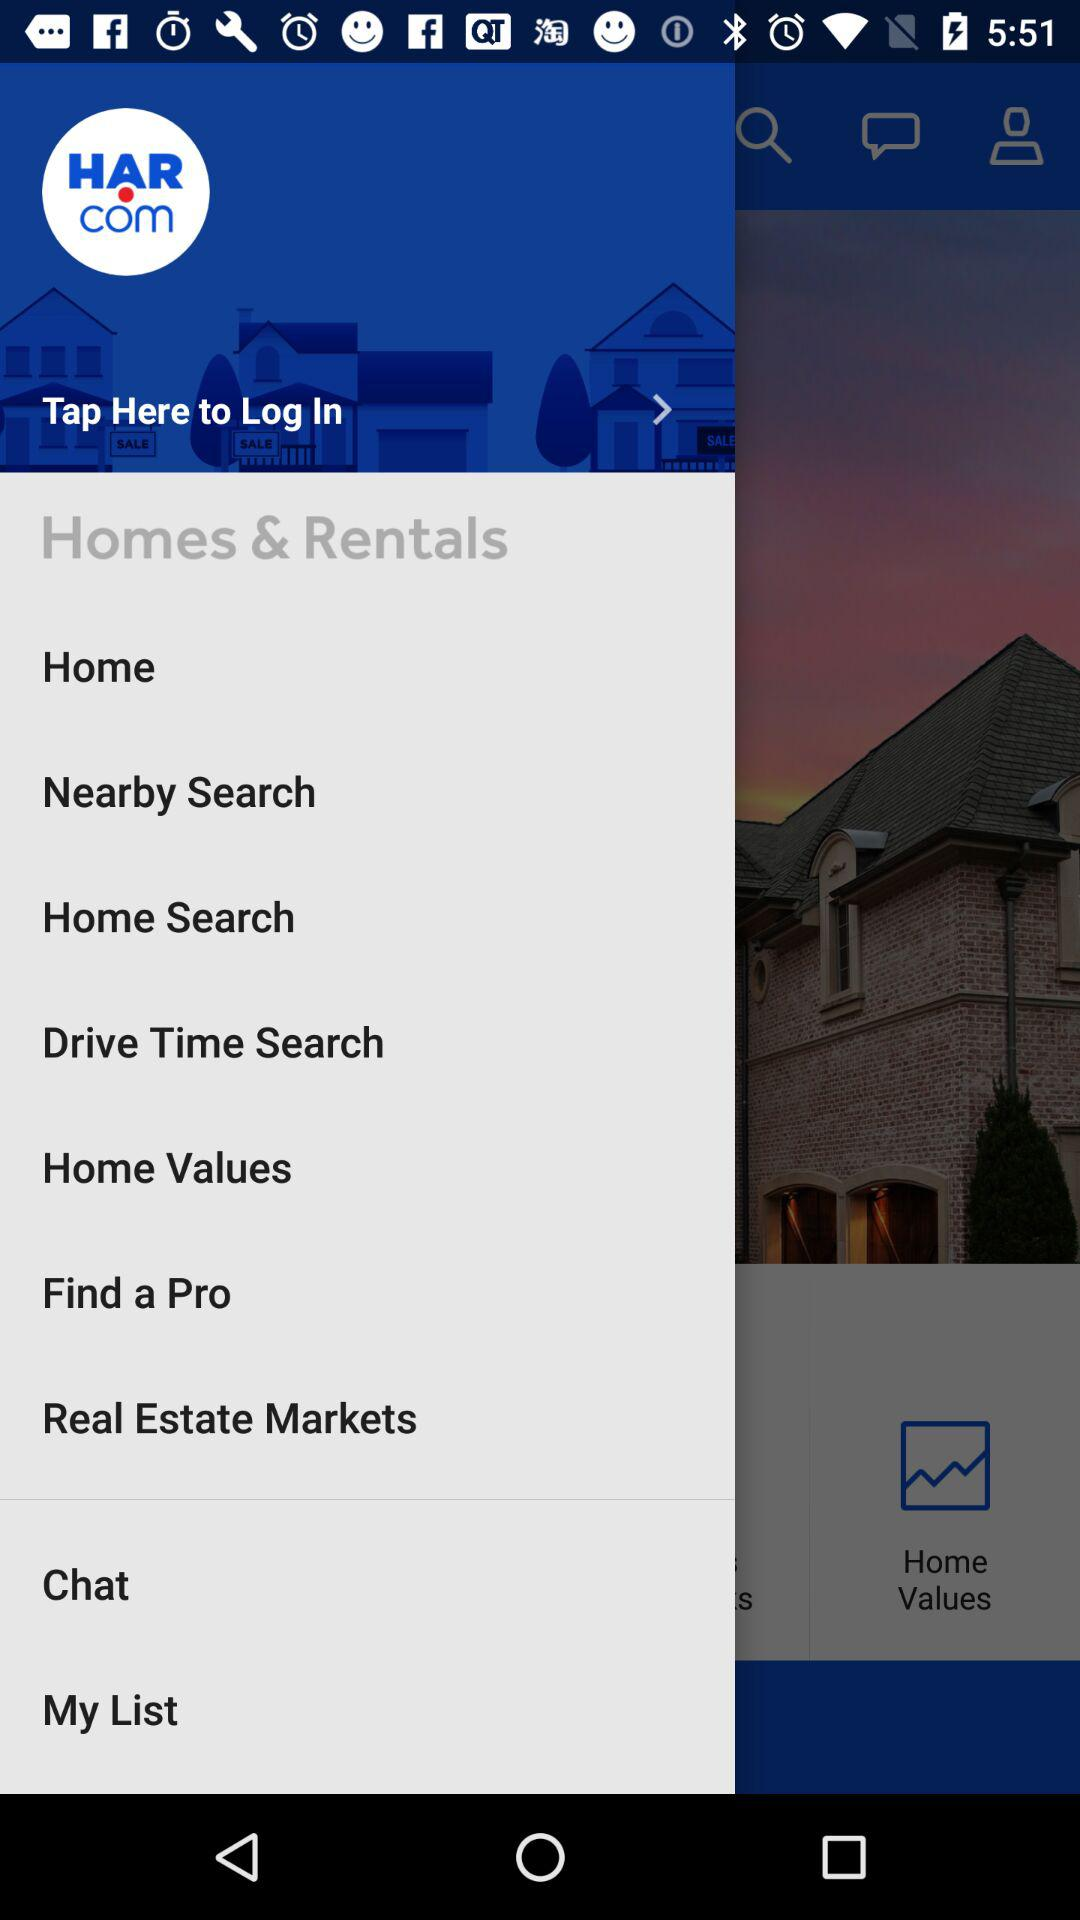What is the application name? The application name is "HAR.com". 